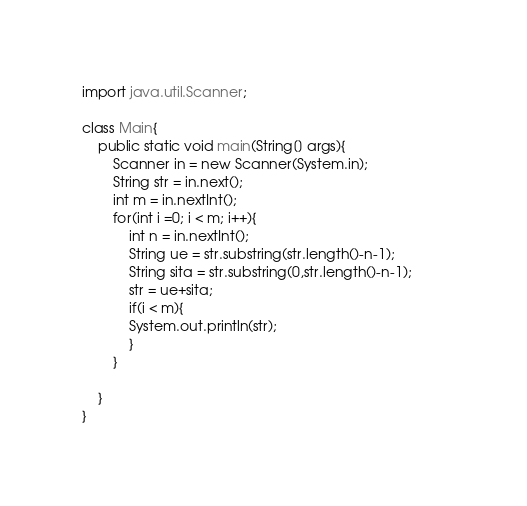Convert code to text. <code><loc_0><loc_0><loc_500><loc_500><_Java_>import java.util.Scanner;                                                   

class Main{
    public static void main(String[] args){
        Scanner in = new Scanner(System.in);
        String str = in.next();
        int m = in.nextInt();
        for(int i =0; i < m; i++){
            int n = in.nextInt();
            String ue = str.substring(str.length()-n-1);
            String sita = str.substring(0,str.length()-n-1);
            str = ue+sita;
            if(i < m){
            System.out.println(str);
            }
        }

    }
}</code> 